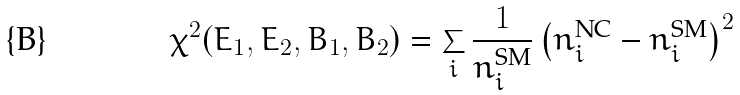Convert formula to latex. <formula><loc_0><loc_0><loc_500><loc_500>\chi ^ { 2 } ( E _ { 1 } , E _ { 2 } , B _ { 1 } , B _ { 2 } ) = \sum _ { i } \frac { 1 } { n ^ { \text {SM} } _ { i } } \left ( n ^ { \text {NC} } _ { i } - n ^ { \text {SM} } _ { i } \right ) ^ { 2 }</formula> 